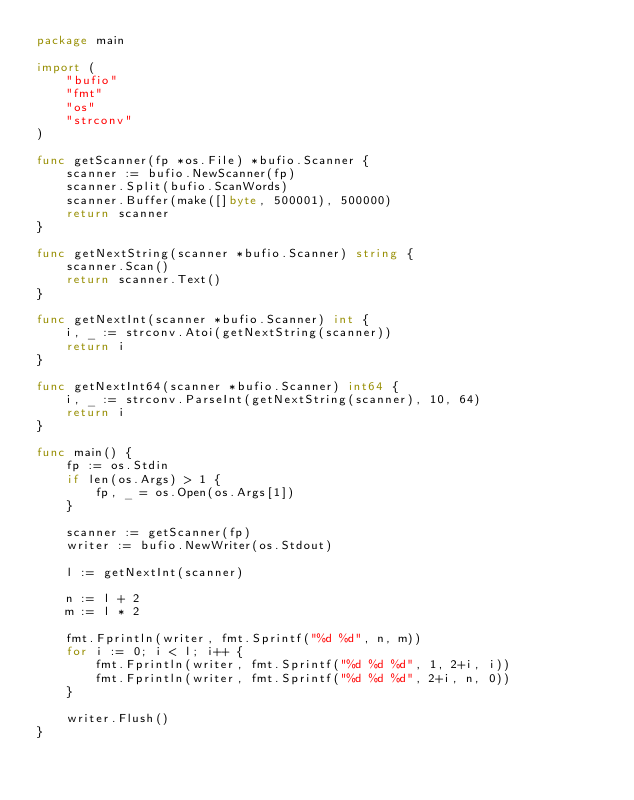Convert code to text. <code><loc_0><loc_0><loc_500><loc_500><_Go_>package main

import (
	"bufio"
	"fmt"
	"os"
	"strconv"
)

func getScanner(fp *os.File) *bufio.Scanner {
	scanner := bufio.NewScanner(fp)
	scanner.Split(bufio.ScanWords)
	scanner.Buffer(make([]byte, 500001), 500000)
	return scanner
}

func getNextString(scanner *bufio.Scanner) string {
	scanner.Scan()
	return scanner.Text()
}

func getNextInt(scanner *bufio.Scanner) int {
	i, _ := strconv.Atoi(getNextString(scanner))
	return i
}

func getNextInt64(scanner *bufio.Scanner) int64 {
	i, _ := strconv.ParseInt(getNextString(scanner), 10, 64)
	return i
}

func main() {
	fp := os.Stdin
	if len(os.Args) > 1 {
		fp, _ = os.Open(os.Args[1])
	}

	scanner := getScanner(fp)
	writer := bufio.NewWriter(os.Stdout)

	l := getNextInt(scanner)

	n := l + 2
	m := l * 2

	fmt.Fprintln(writer, fmt.Sprintf("%d %d", n, m))
	for i := 0; i < l; i++ {
		fmt.Fprintln(writer, fmt.Sprintf("%d %d %d", 1, 2+i, i))
		fmt.Fprintln(writer, fmt.Sprintf("%d %d %d", 2+i, n, 0))
	}

	writer.Flush()
}
</code> 